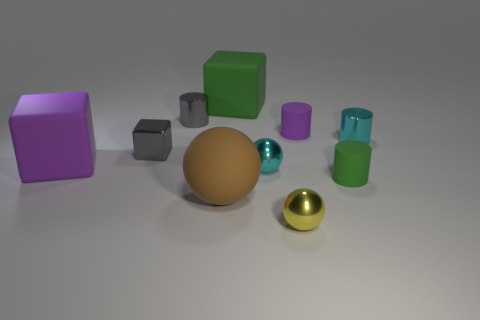Is there a blue shiny cube? no 